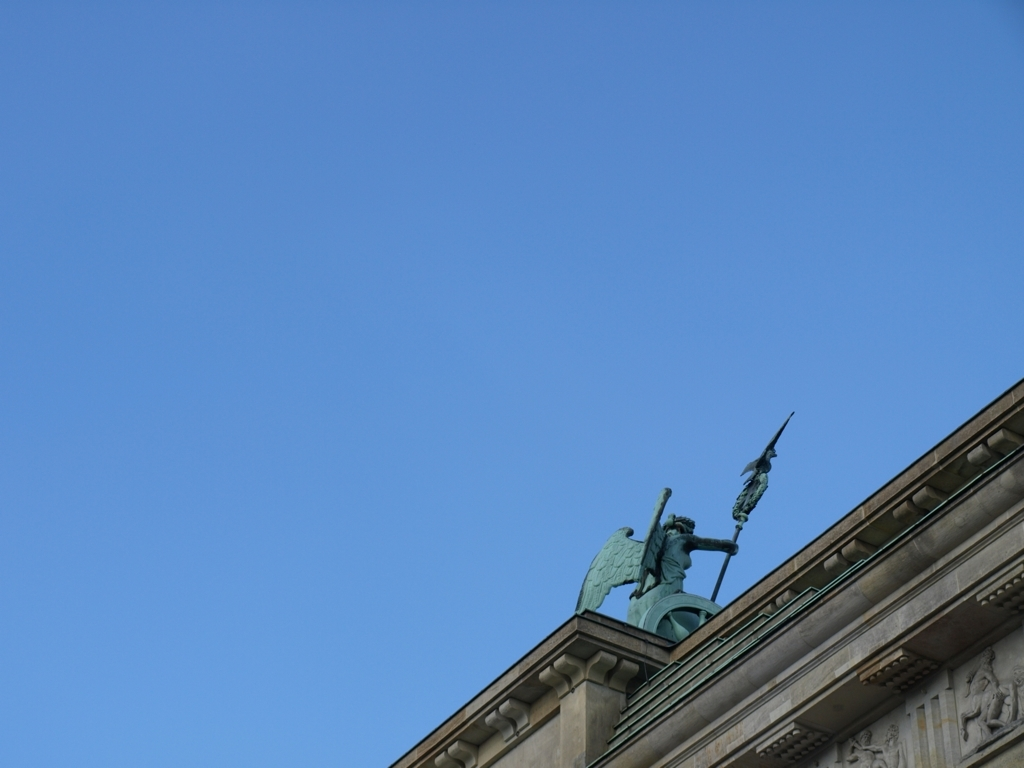Could you offer insights into what the architectural style or time period this structure might belong to? Based on the visible elements of the building behind the statue, such as the friezes and the use of a grand sculpture on top, it suggests a neoclassical or Beaux-Arts architectural style, which were popular from the late 18th century through the early 20th century. These styles are characterized by grandiose and elaborate designs inspired by classical antiquity. 